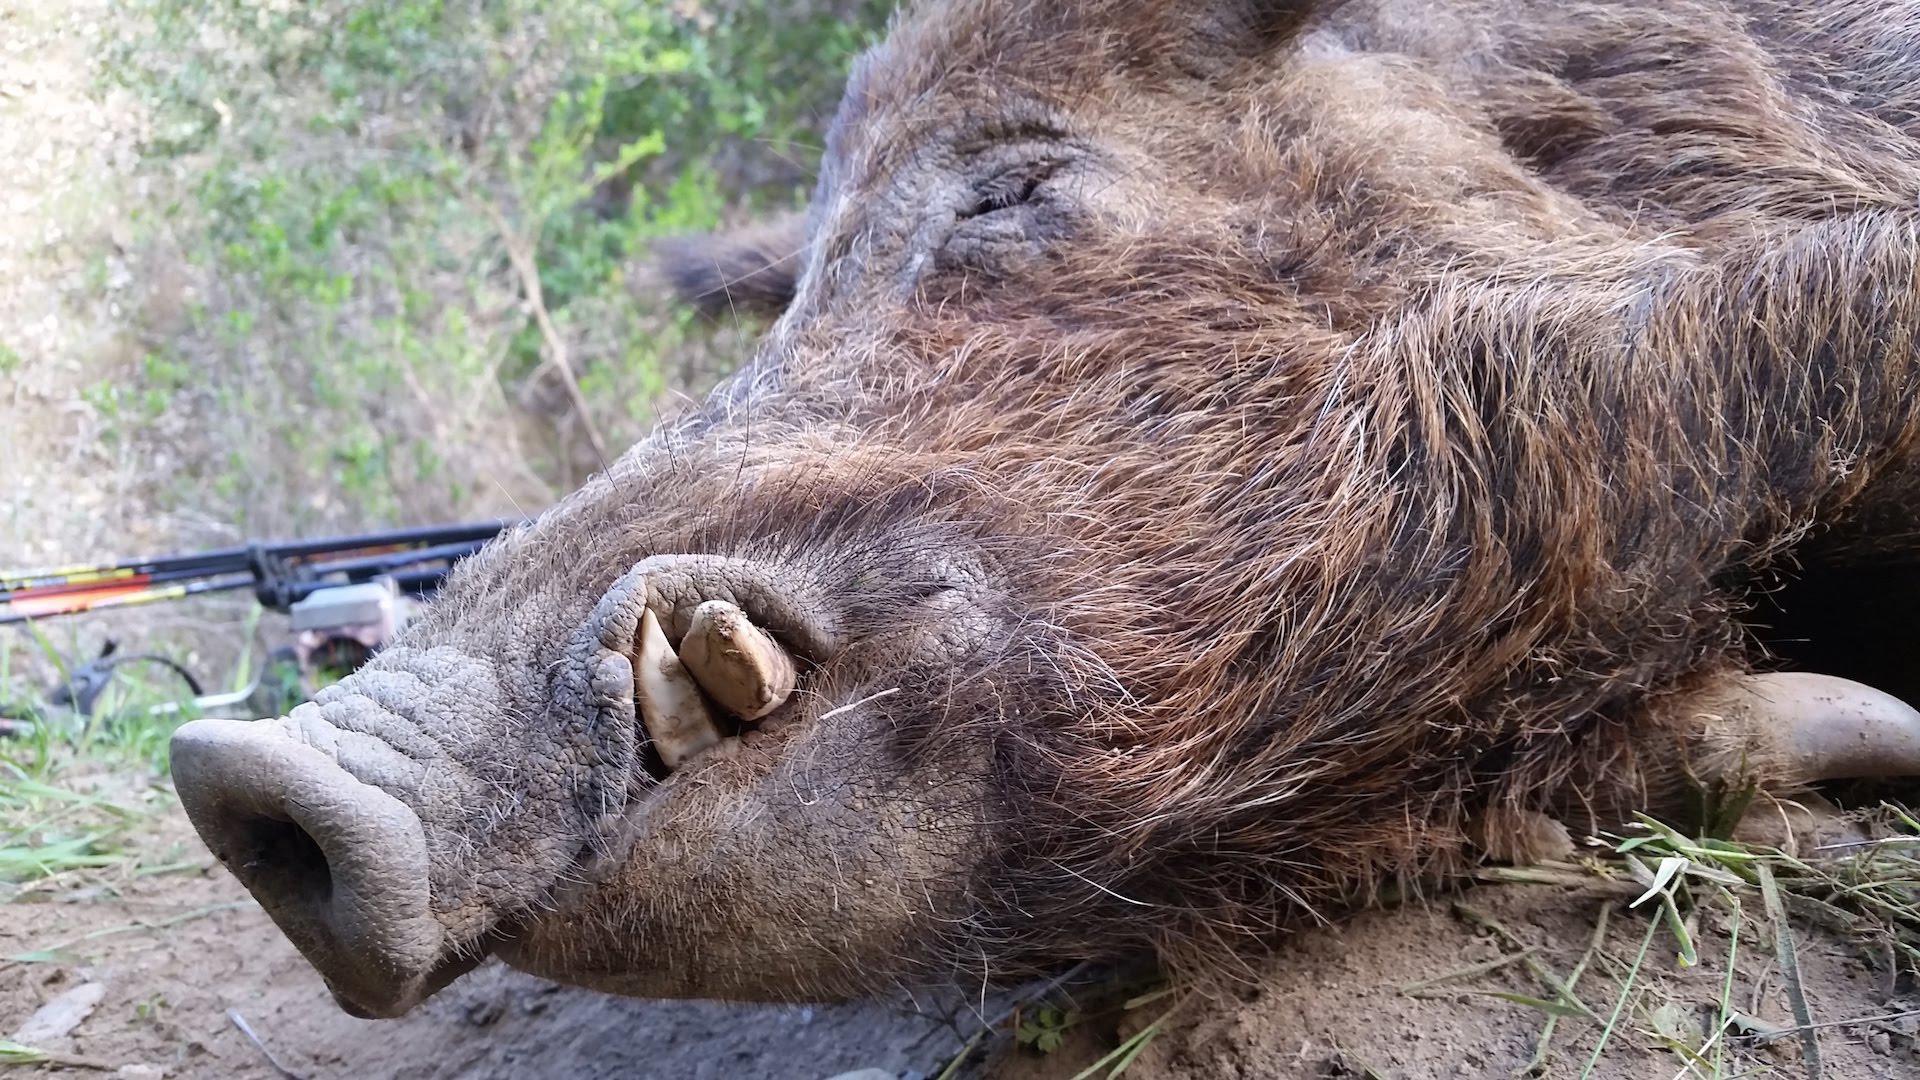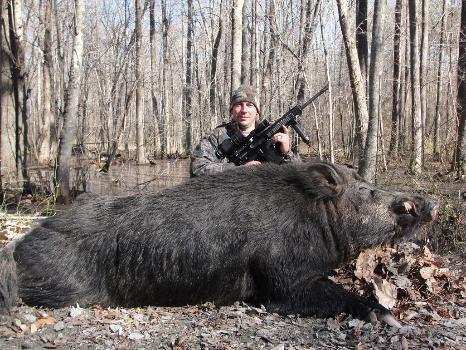The first image is the image on the left, the second image is the image on the right. Examine the images to the left and right. Is the description "At least one of the animals pictured is dead." accurate? Answer yes or no. Yes. 